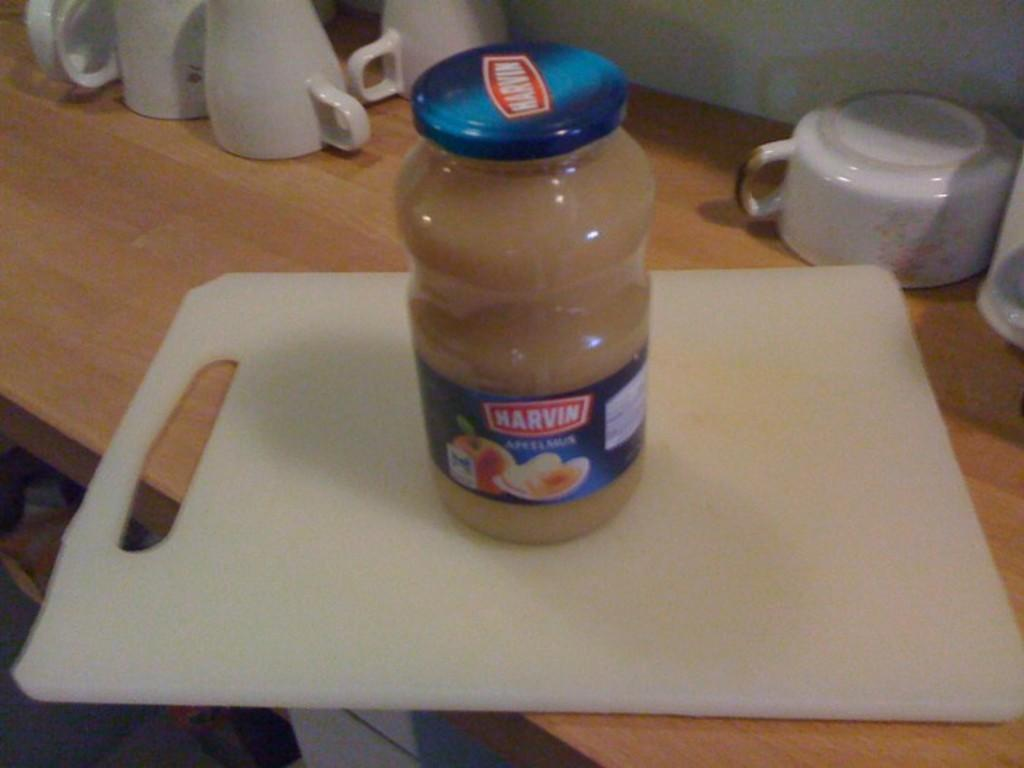<image>
Write a terse but informative summary of the picture. A jar of Harvin applesauce sits on a cutting board. 